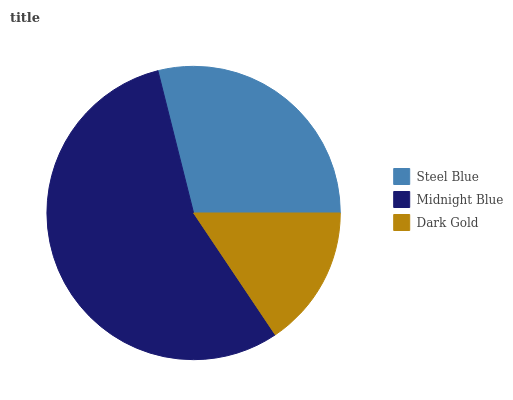Is Dark Gold the minimum?
Answer yes or no. Yes. Is Midnight Blue the maximum?
Answer yes or no. Yes. Is Midnight Blue the minimum?
Answer yes or no. No. Is Dark Gold the maximum?
Answer yes or no. No. Is Midnight Blue greater than Dark Gold?
Answer yes or no. Yes. Is Dark Gold less than Midnight Blue?
Answer yes or no. Yes. Is Dark Gold greater than Midnight Blue?
Answer yes or no. No. Is Midnight Blue less than Dark Gold?
Answer yes or no. No. Is Steel Blue the high median?
Answer yes or no. Yes. Is Steel Blue the low median?
Answer yes or no. Yes. Is Dark Gold the high median?
Answer yes or no. No. Is Dark Gold the low median?
Answer yes or no. No. 